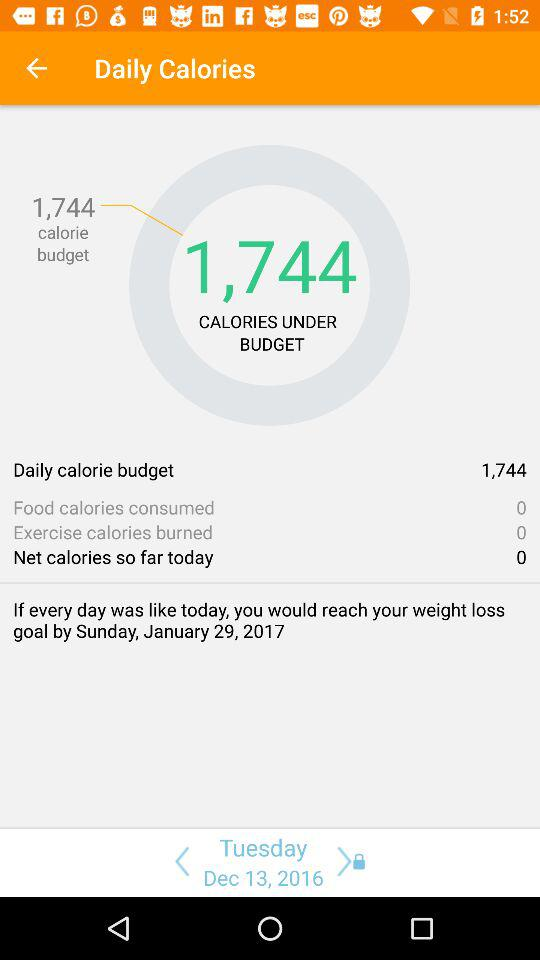How many calories are burned by exercising? There are 0 calories burned by exercising. 